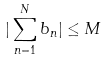<formula> <loc_0><loc_0><loc_500><loc_500>| \sum _ { n = 1 } ^ { N } b _ { n } | \leq M</formula> 